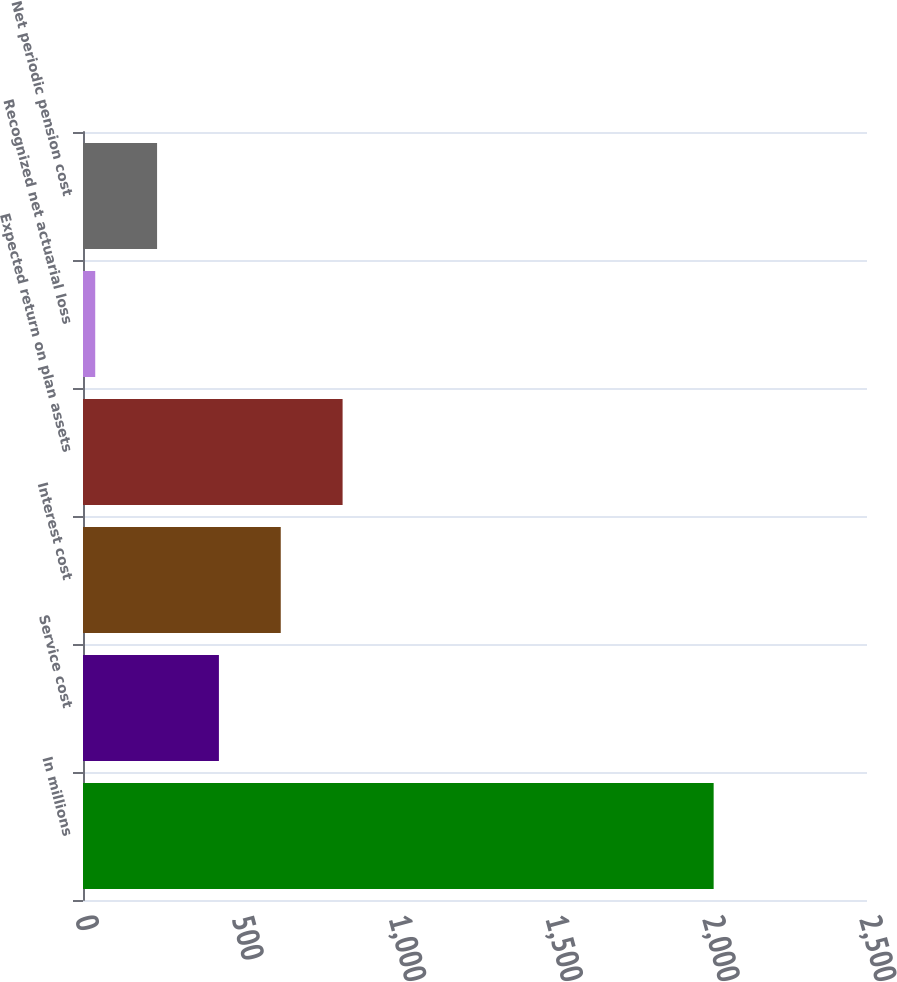<chart> <loc_0><loc_0><loc_500><loc_500><bar_chart><fcel>In millions<fcel>Service cost<fcel>Interest cost<fcel>Expected return on plan assets<fcel>Recognized net actuarial loss<fcel>Net periodic pension cost<nl><fcel>2011<fcel>433.4<fcel>630.6<fcel>827.8<fcel>39<fcel>236.2<nl></chart> 